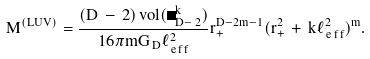Convert formula to latex. <formula><loc_0><loc_0><loc_500><loc_500>M ^ { ( L U V ) } = \frac { ( D \, - \, 2 ) \, v o l ( \Sigma _ { D - \, 2 } ^ { k } ) } { 1 6 \pi m G _ { \, D } \ell _ { \, e \, f \, f } ^ { 2 } } r _ { + } ^ { D - 2 m - 1 } ( r _ { + } ^ { 2 } \, + \, k \ell _ { \, e \, f \, f } ^ { 2 } ) ^ { m } .</formula> 